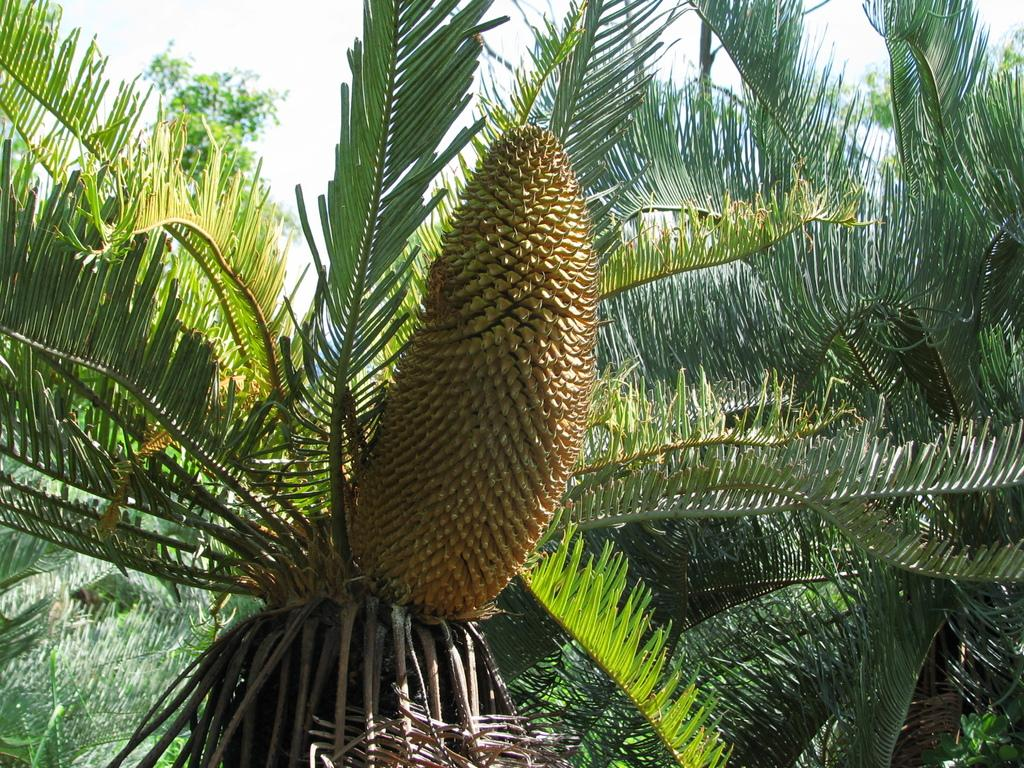What type of vegetation can be seen in the image? There are trees in the image. What type of food item is present in the image? There is a fruit in the image. What type of canvas is being used to paint the trees in the image? There is no canvas or painting present in the image; it is a photograph of real trees. What type of birds can be seen flying around the fruit in the image? There are no birds present in the image; it only trees and a fruit are visible. 